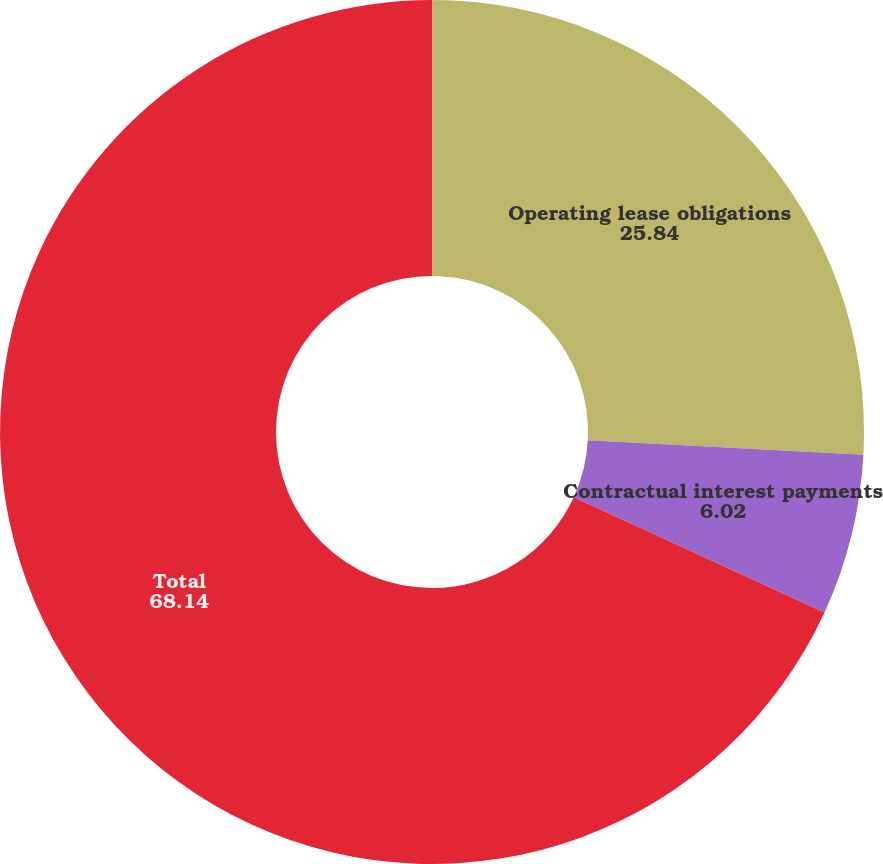<chart> <loc_0><loc_0><loc_500><loc_500><pie_chart><fcel>Operating lease obligations<fcel>Contractual interest payments<fcel>Total<nl><fcel>25.84%<fcel>6.02%<fcel>68.14%<nl></chart> 